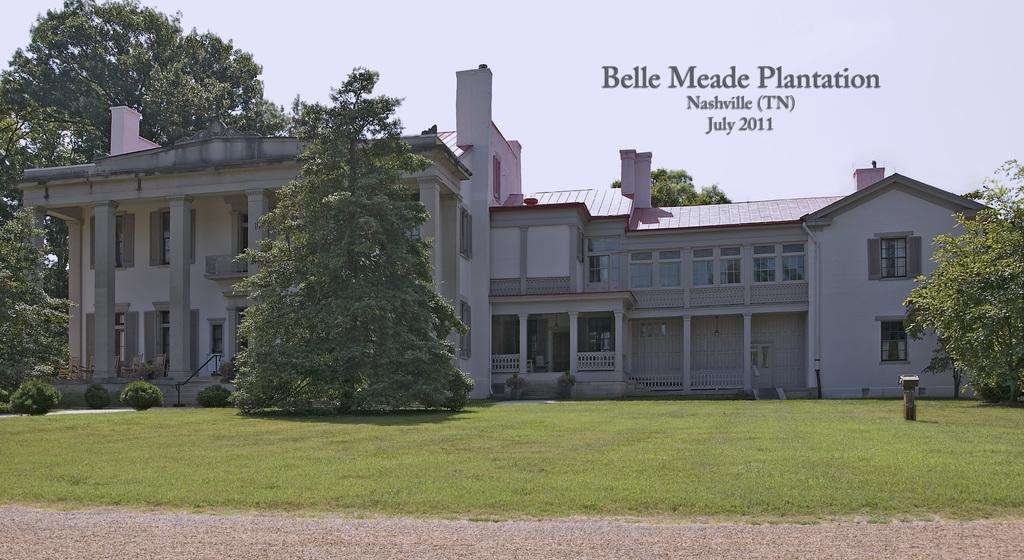What is located in the center of the image? There are buildings in the center of the image. What type of vegetation can be seen in the image? There are trees in the image. What is at the bottom of the image? There is a walkway at the bottom of the image. What type of ground cover is present in the image? There is grass in the image. What is written or displayed at the top of the image? There is text at the top of the image. What type of fear can be seen on the faces of the trees in the image? There is no fear present on the trees in the image, as trees do not have emotions or facial expressions. How many notes are visible on the walkway in the image? There is no mention of notes in the image; it features buildings, trees, a walkway, grass, and text. 